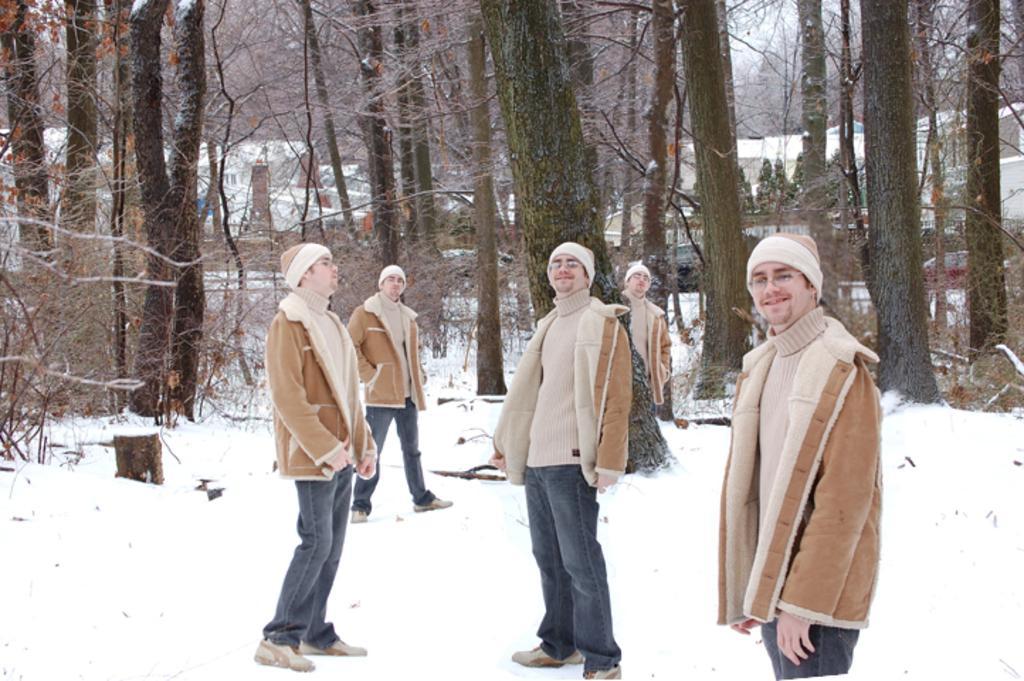Please provide a concise description of this image. In this image there are different angles of a person on the snow surface, in the background of the image there are trees and houses. 